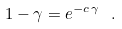<formula> <loc_0><loc_0><loc_500><loc_500>1 - \gamma = e ^ { - c \, \gamma } \ .</formula> 